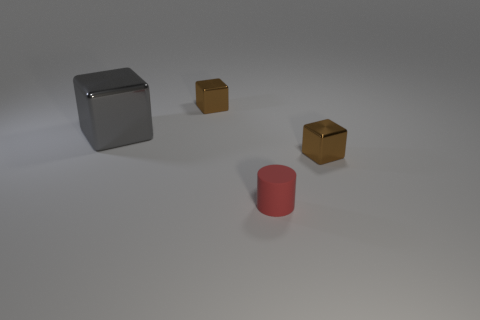Subtract all gray metallic cubes. How many cubes are left? 2 Subtract 3 blocks. How many blocks are left? 0 Subtract all gray cubes. How many cubes are left? 2 Subtract all cubes. How many objects are left? 1 Subtract all green blocks. Subtract all brown spheres. How many blocks are left? 3 Subtract all red cubes. How many yellow cylinders are left? 0 Subtract all yellow metallic cubes. Subtract all metal objects. How many objects are left? 1 Add 4 red rubber objects. How many red rubber objects are left? 5 Add 1 big metallic cubes. How many big metallic cubes exist? 2 Add 2 large gray matte objects. How many objects exist? 6 